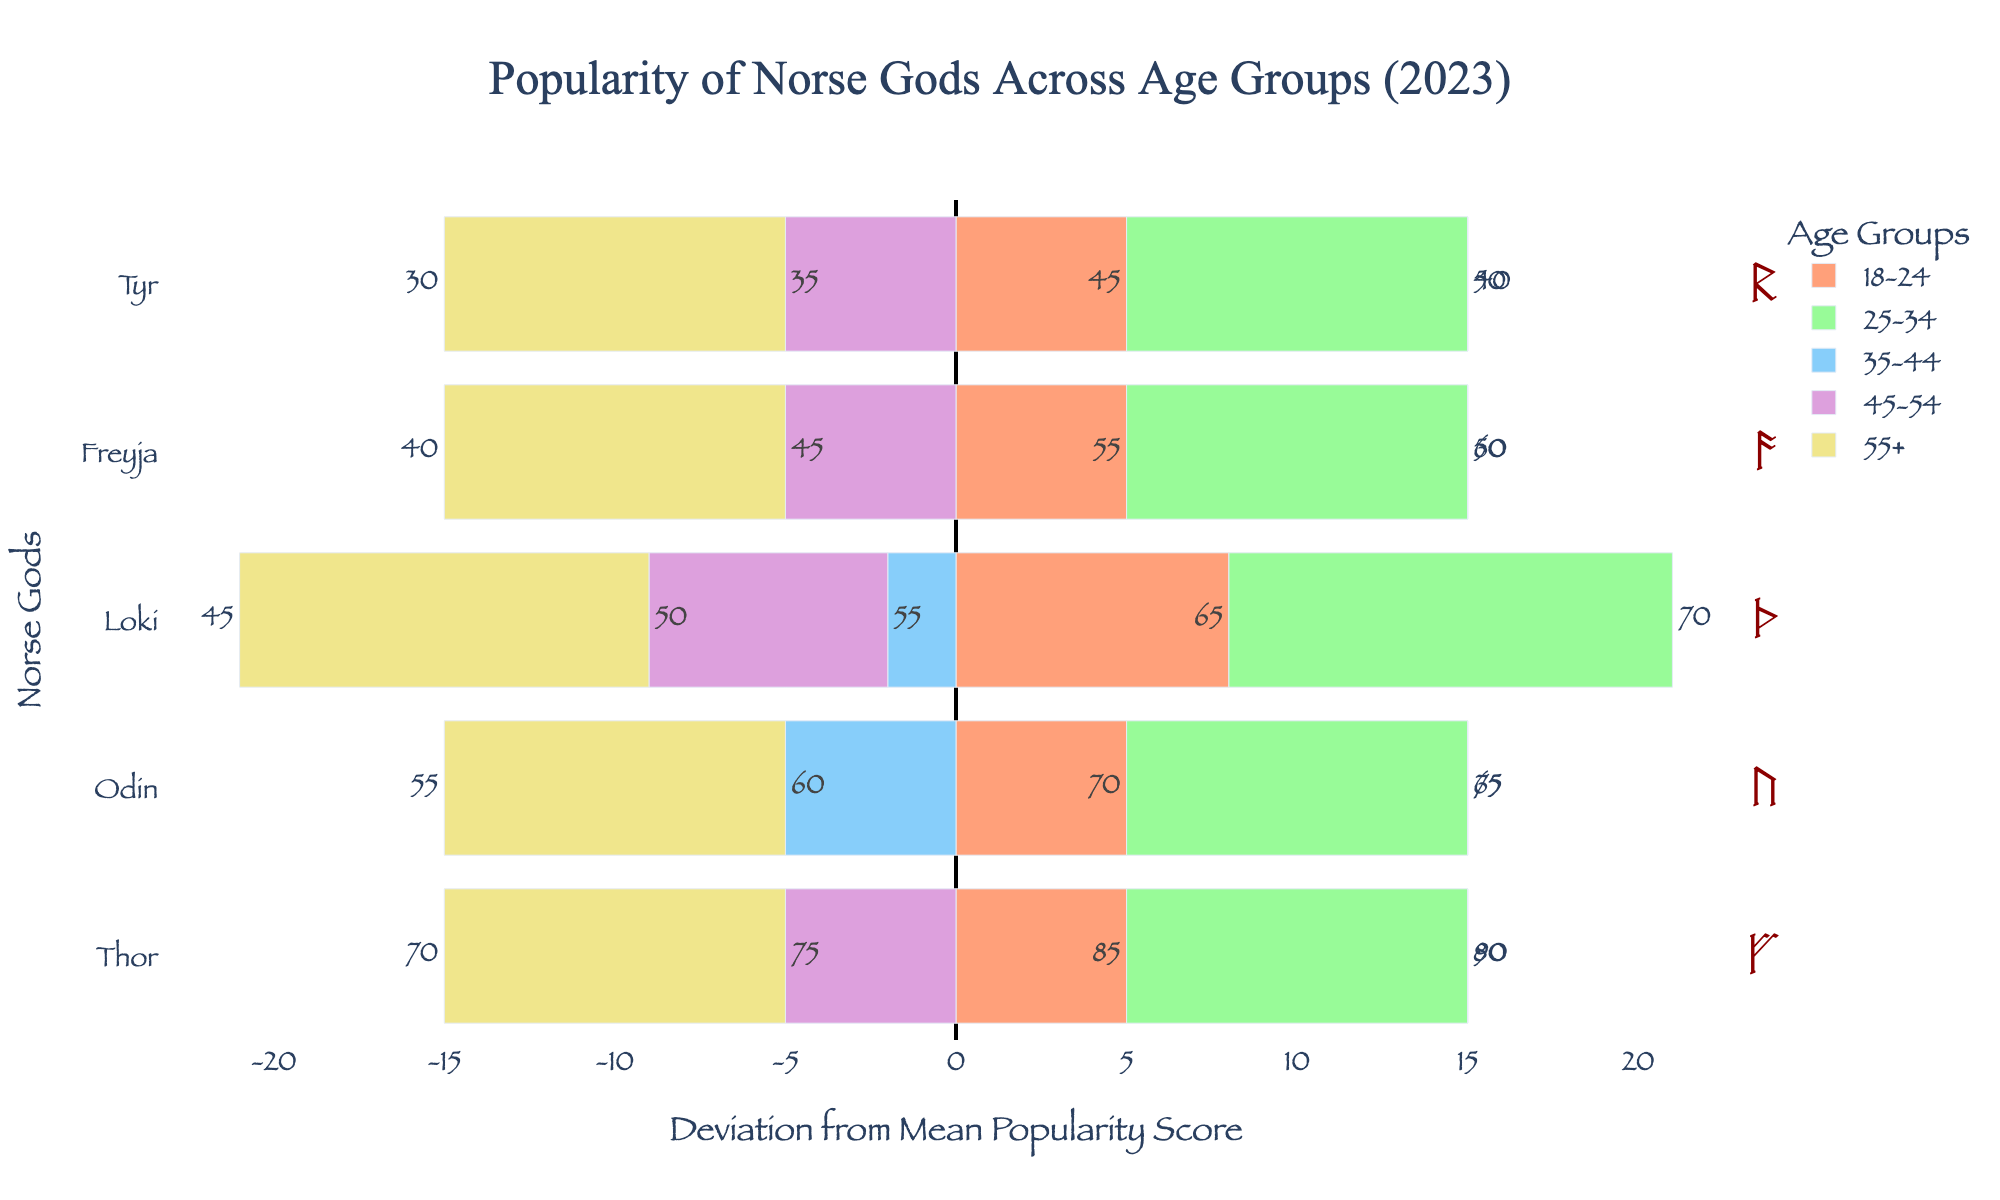How do the popularity scores for Odin differ across the age groups? The popularity scores for Odin are displayed as bars. By comparing their positions and lengths, we can see they vary, with the 25-34 age group showing the highest deviation above the mean, followed by the 18-24 age group slightly above the mean, 45-54 group near the mean, 35-44 below the mean, and 55+ having the lowest popularity.
Answer: Highest in 25-34 Which god has the largest deviation from the mean in the 18-24 age group? Looking at the 18-24 bars' positions and lengths, Thor's is the longest and farthest from the zero line, indicating he has the highest deviation from the mean in this age group.
Answer: Thor For which age group does Freyja have the least popularity deviation? By examining the bars corresponding to Freyja, the one closest to zero indicates the least deviation. The 45-54 age group has the bar closest to the zero line for Freyja.
Answer: 45-54 How does the popularity of Tyr compare across the age 25-34 and 55+ groups? Comparing Tyr's bars for the 25-34 and 55+ age groups, the 25-34 bar is longer and higher above the mean, whereas the 55+ bar is shorter and much lower. This shows Tyr is more popular in the 25-34 age group.
Answer: More popular in 25-34 What is the average popularity score for Loki across all age groups? The figure shows individual popularity scores per age group. Summing Loki's scores (65 + 70 + 55 + 50 + 45) gives 285. Dividing by the number of age groups (5) results in an average of 57.
Answer: 57 Which god's popularity is most consistently average across age groups? Consistency is visually represented by the proximity of the bar lengths to zero. Examining all gods, Odin's bars are the most evenly spread around the mean, suggesting his popularity is the most consistent.
Answer: Odin What is the visual pattern of Thor's popularity across the age groups? Thor's bars vary in length and position. From highest to lowest bars, they form a descending pattern from 25-34, 18-24, 35-44, 45-54, and the shortest for 55+.
Answer: Descending with age What's the overall trend of Norse gods' popularity among the 35-44 age group? By seeing if the 35-44 bars are largely above or below zero, they generally trend below it. This reflects a lower than average popularity for most gods in this age group, except for Thor.
Answer: Mostly below average Which god shows the most variance in popularity scores among age groups? Large variances are depicted by bars with significant deviations from zero. Thor has the highest bars and widest range, indicating the most variance in scores.
Answer: Thor Are there any age groups where the relative popularity of a god matches exactly with its average popularity score? Bars having no length with respect to zero mean they match the mean exactly. For Freyja in the 45-54 age group, her bar shows negligible deviation from the mean score which is a match.
Answer: Freyja in 45-54 